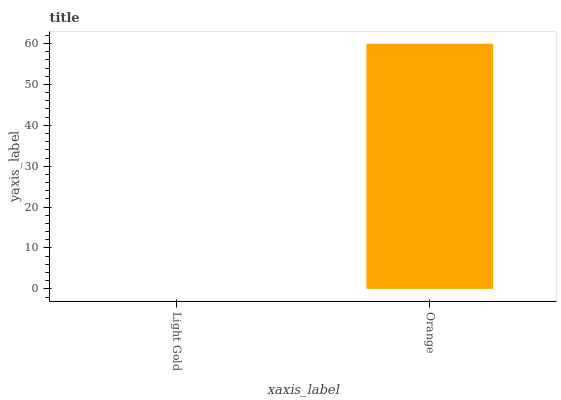Is Light Gold the minimum?
Answer yes or no. Yes. Is Orange the maximum?
Answer yes or no. Yes. Is Orange the minimum?
Answer yes or no. No. Is Orange greater than Light Gold?
Answer yes or no. Yes. Is Light Gold less than Orange?
Answer yes or no. Yes. Is Light Gold greater than Orange?
Answer yes or no. No. Is Orange less than Light Gold?
Answer yes or no. No. Is Orange the high median?
Answer yes or no. Yes. Is Light Gold the low median?
Answer yes or no. Yes. Is Light Gold the high median?
Answer yes or no. No. Is Orange the low median?
Answer yes or no. No. 